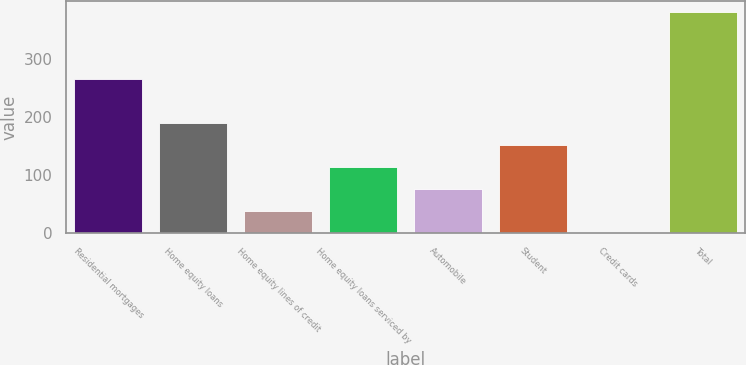Convert chart to OTSL. <chart><loc_0><loc_0><loc_500><loc_500><bar_chart><fcel>Residential mortgages<fcel>Home equity loans<fcel>Home equity lines of credit<fcel>Home equity loans serviced by<fcel>Automobile<fcel>Student<fcel>Credit cards<fcel>Total<nl><fcel>265.6<fcel>190<fcel>38.8<fcel>114.4<fcel>76.6<fcel>152.2<fcel>1<fcel>379<nl></chart> 